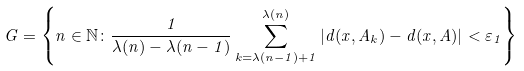Convert formula to latex. <formula><loc_0><loc_0><loc_500><loc_500>G = \left \{ n \in \mathbb { N } \colon \frac { 1 } { \lambda ( n ) - \lambda ( n - 1 ) } \sum _ { k = \lambda ( n - 1 ) + 1 } ^ { \lambda ( n ) } | d ( x , A _ { k } ) - d ( x , A ) | < \varepsilon _ { 1 } \right \}</formula> 